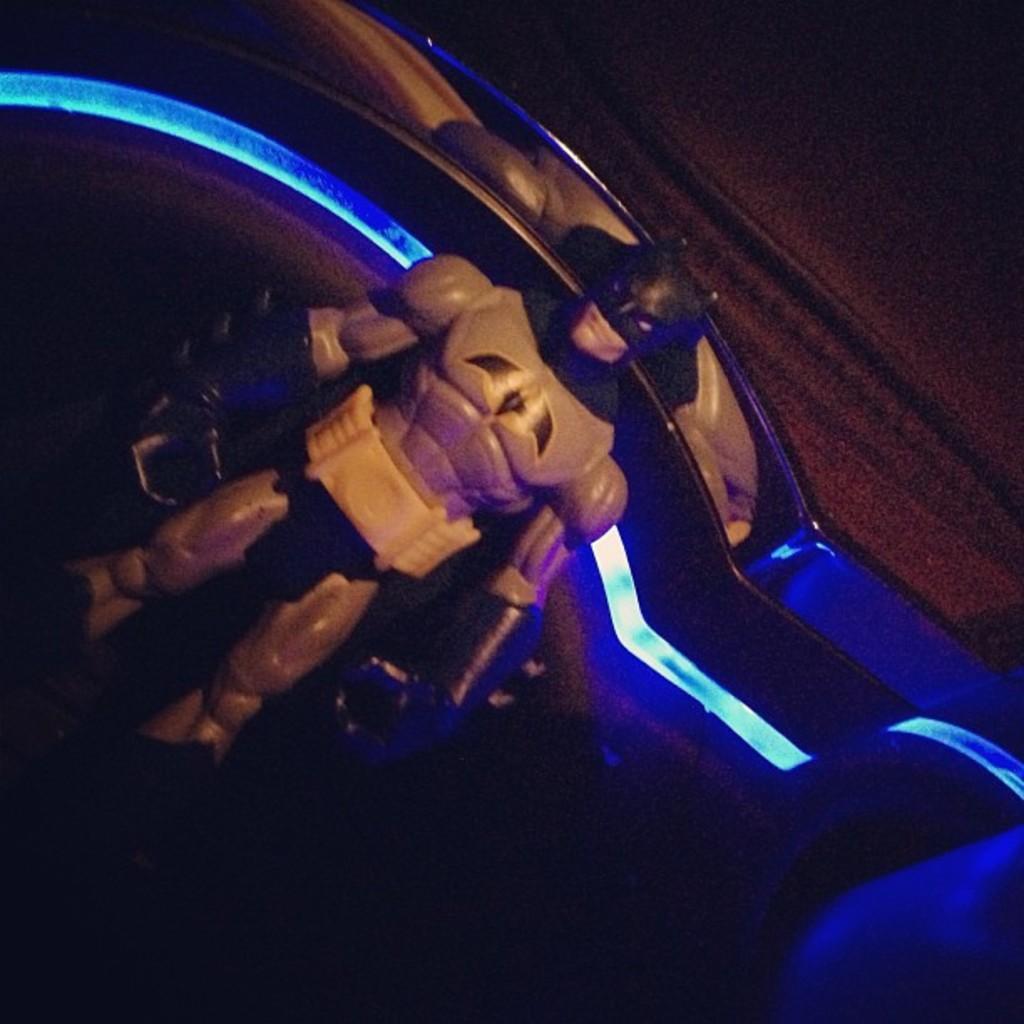Describe this image in one or two sentences. In this picture I can see the batsman's statue which is placed near to the wall. 